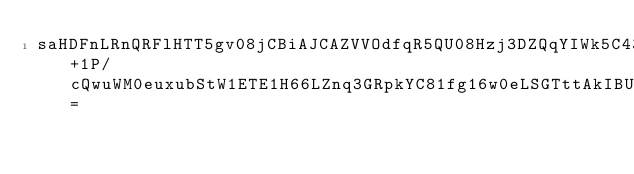<code> <loc_0><loc_0><loc_500><loc_500><_SML_>saHDFnLRnQRFlHTT5gv08jCBiAJCAZVVOdfqR5QU08Hzj3DZQqYIWk5C432yfbZ+1P/cQwuWM0euxubStW1ETE1H66LZnq3GRpkYC81fg16w0eLSGTttAkIBUvVMhcEgdytLoJJw8zUROu6ekpt82BZBj6ebXy6e78SBZo9VJzJlEbX3r83VxznW1WnGvVUSSkxhMyUkVtOecoQ=</code> 